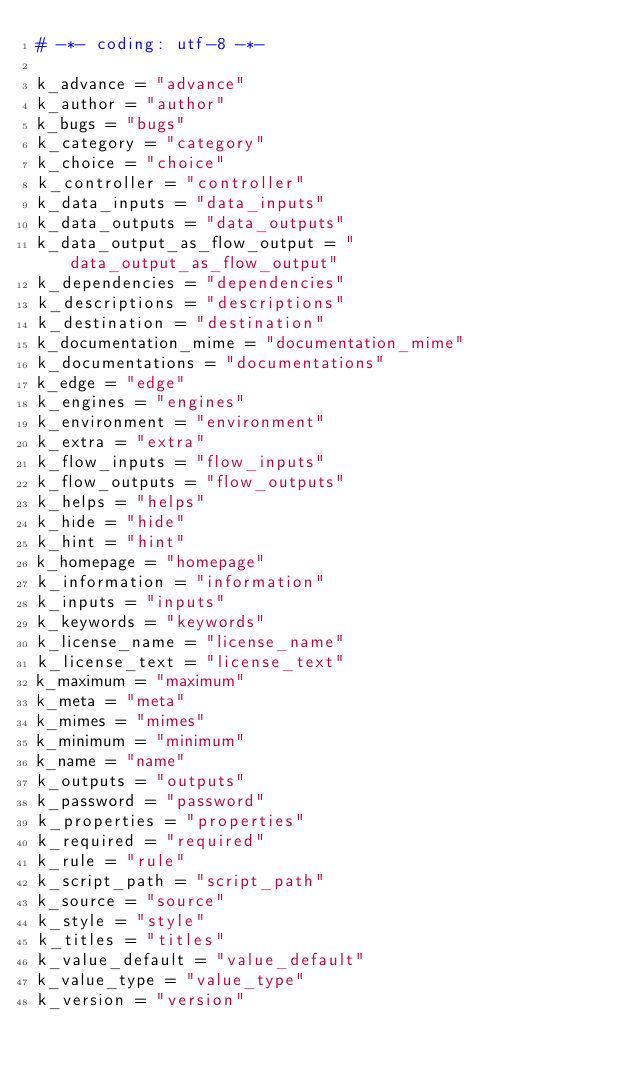Convert code to text. <code><loc_0><loc_0><loc_500><loc_500><_Python_># -*- coding: utf-8 -*-

k_advance = "advance"
k_author = "author"
k_bugs = "bugs"
k_category = "category"
k_choice = "choice"
k_controller = "controller"
k_data_inputs = "data_inputs"
k_data_outputs = "data_outputs"
k_data_output_as_flow_output = "data_output_as_flow_output"
k_dependencies = "dependencies"
k_descriptions = "descriptions"
k_destination = "destination"
k_documentation_mime = "documentation_mime"
k_documentations = "documentations"
k_edge = "edge"
k_engines = "engines"
k_environment = "environment"
k_extra = "extra"
k_flow_inputs = "flow_inputs"
k_flow_outputs = "flow_outputs"
k_helps = "helps"
k_hide = "hide"
k_hint = "hint"
k_homepage = "homepage"
k_information = "information"
k_inputs = "inputs"
k_keywords = "keywords"
k_license_name = "license_name"
k_license_text = "license_text"
k_maximum = "maximum"
k_meta = "meta"
k_mimes = "mimes"
k_minimum = "minimum"
k_name = "name"
k_outputs = "outputs"
k_password = "password"
k_properties = "properties"
k_required = "required"
k_rule = "rule"
k_script_path = "script_path"
k_source = "source"
k_style = "style"
k_titles = "titles"
k_value_default = "value_default"
k_value_type = "value_type"
k_version = "version"
</code> 